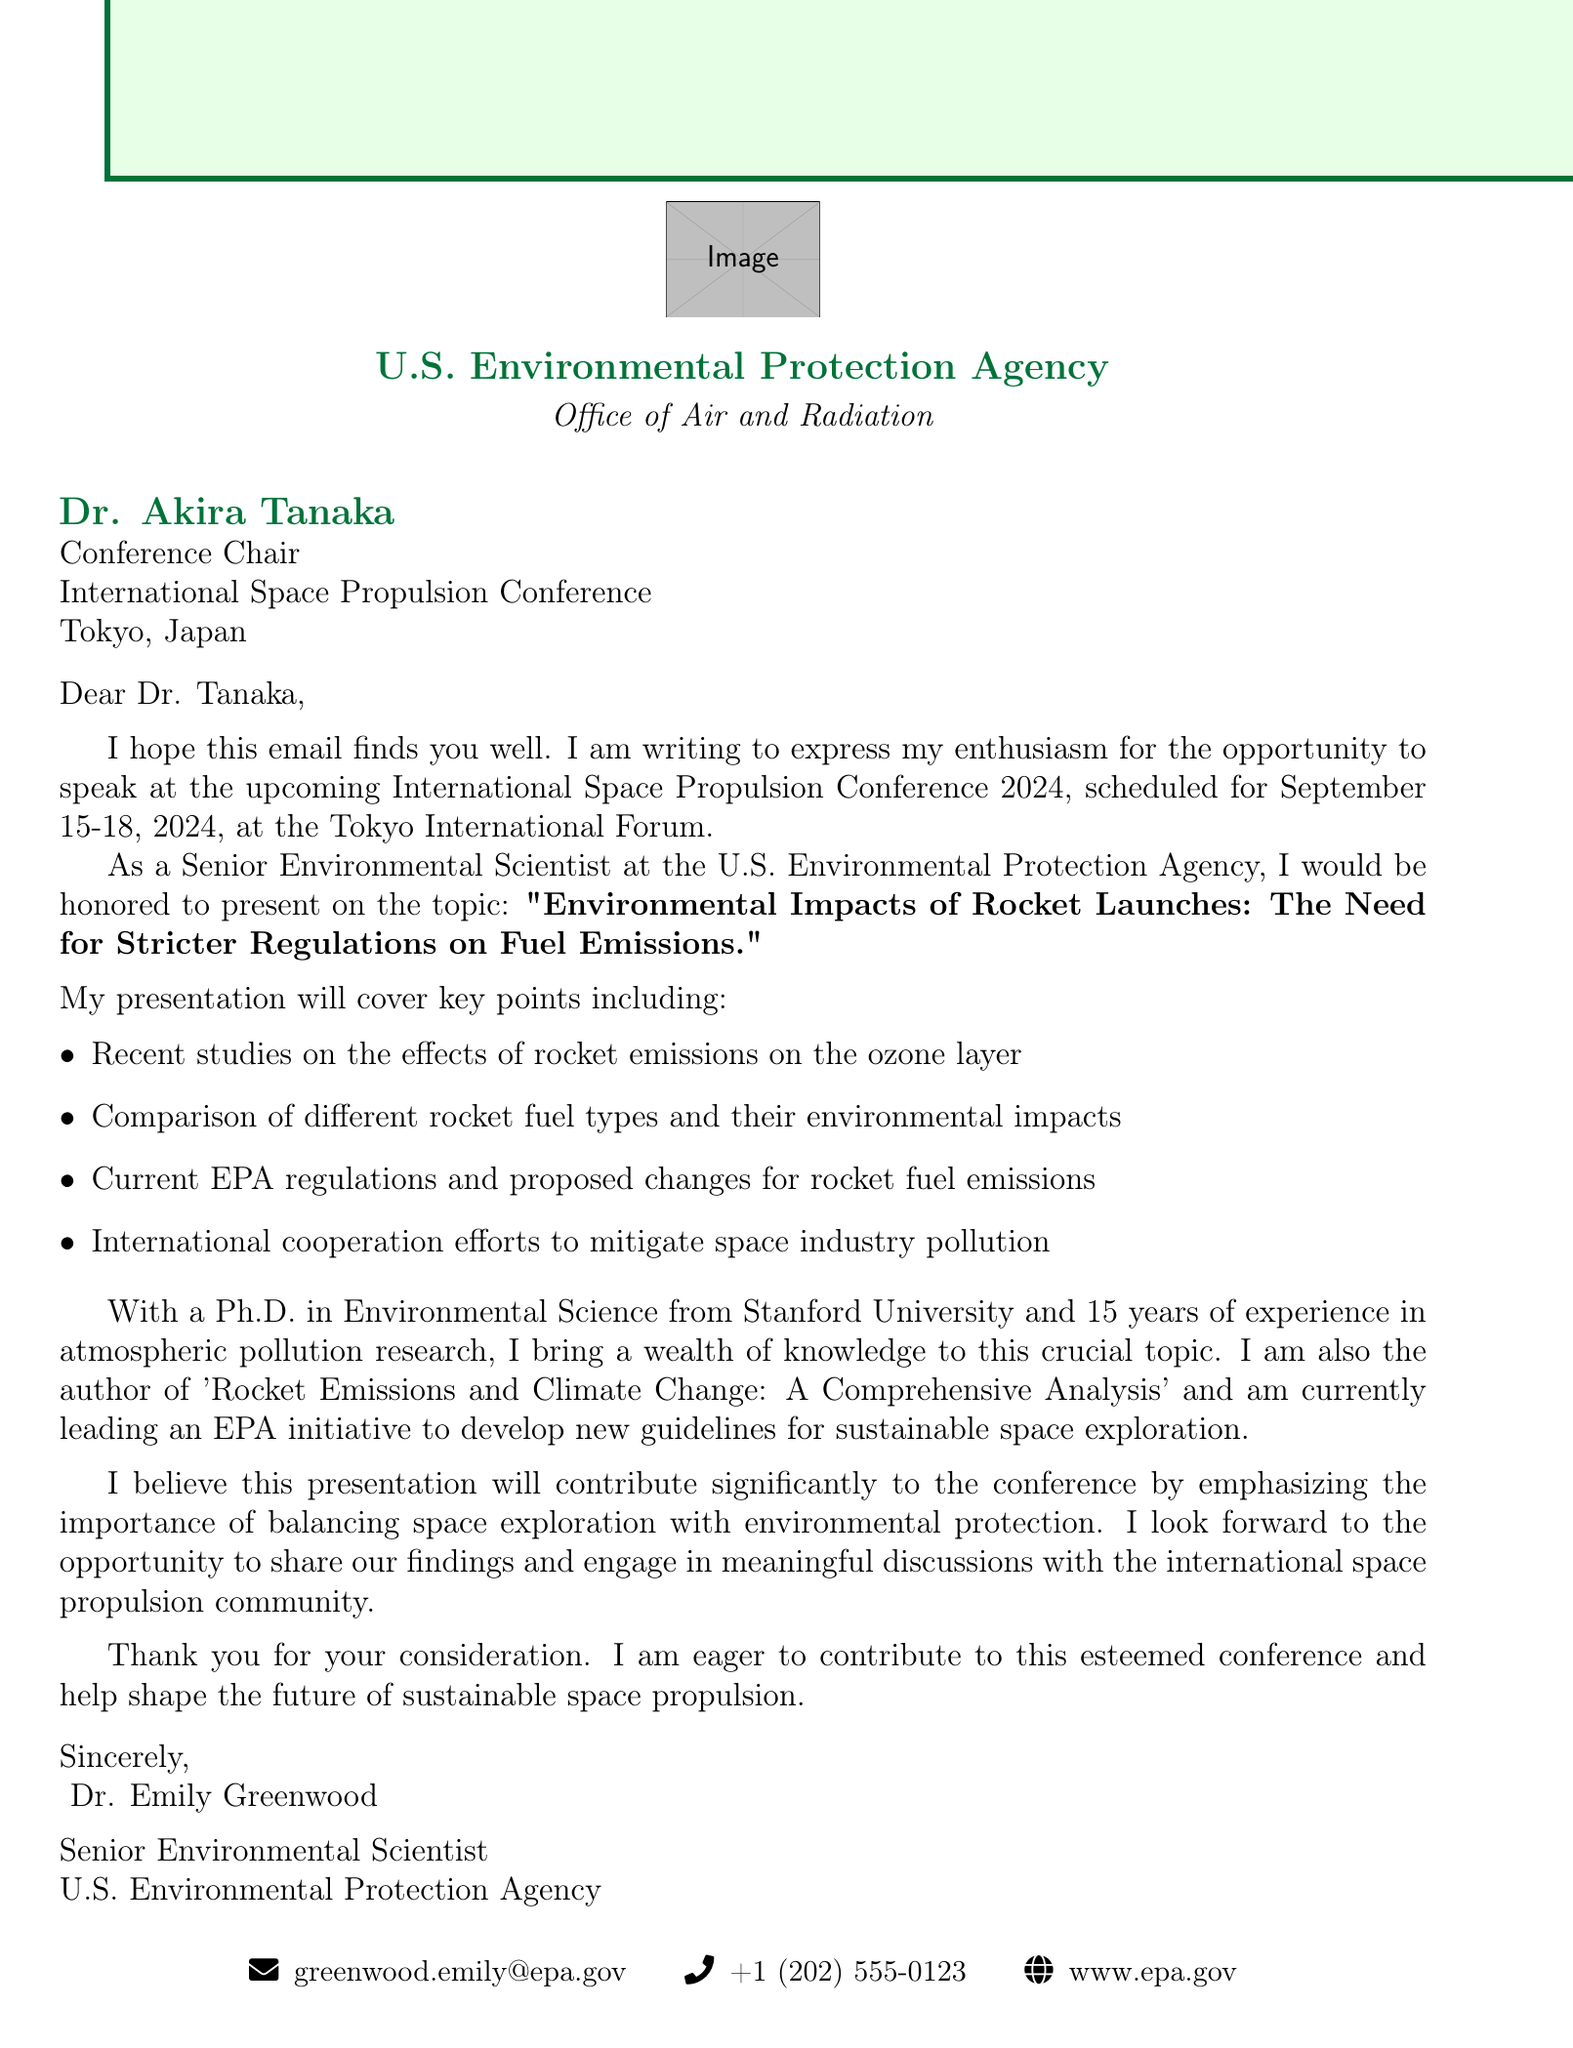What is the name of the conference? The name of the conference is stated in the document as "International Space Propulsion Conference 2024."
Answer: International Space Propulsion Conference 2024 Who is the sender of the email? The sender of the email is clearly identified in the document as "Dr. Emily Greenwood."
Answer: Dr. Emily Greenwood What are the dates of the conference? The dates of the conference are listed in the document as "September 15-18, 2024."
Answer: September 15-18, 2024 What is the focus of Dr. Greenwood's presentation? Dr. Greenwood's presentation focuses on the environmental impacts of rocket launches and the need for stricter regulations on fuel emissions.
Answer: Environmental Impacts of Rocket Launches: The Need for Stricter Regulations on Fuel Emissions How many years of experience does Dr. Greenwood have in atmospheric pollution research? The document specifies that Dr. Greenwood has 15 years of experience in atmospheric pollution research.
Answer: 15 years What significant publication has Dr. Greenwood authored? The document mentions that Dr. Greenwood authored the publication named "Rocket Emissions and Climate Change: A Comprehensive Analysis."
Answer: Rocket Emissions and Climate Change: A Comprehensive Analysis What is one of the key points that will be covered in the presentation? The presentation will cover several key points, one of which is the comparison of different rocket fuel types and their environmental impacts.
Answer: Comparison of different rocket fuel types and their environmental impacts What is the location of the conference? The conference is scheduled to be held at "Tokyo International Forum," as noted in the document.
Answer: Tokyo International Forum What is the email address of Dr. Greenwood? Dr. Greenwood's email address is presented in the document as "greenwood.emily@epa.gov."
Answer: greenwood.emily@epa.gov 